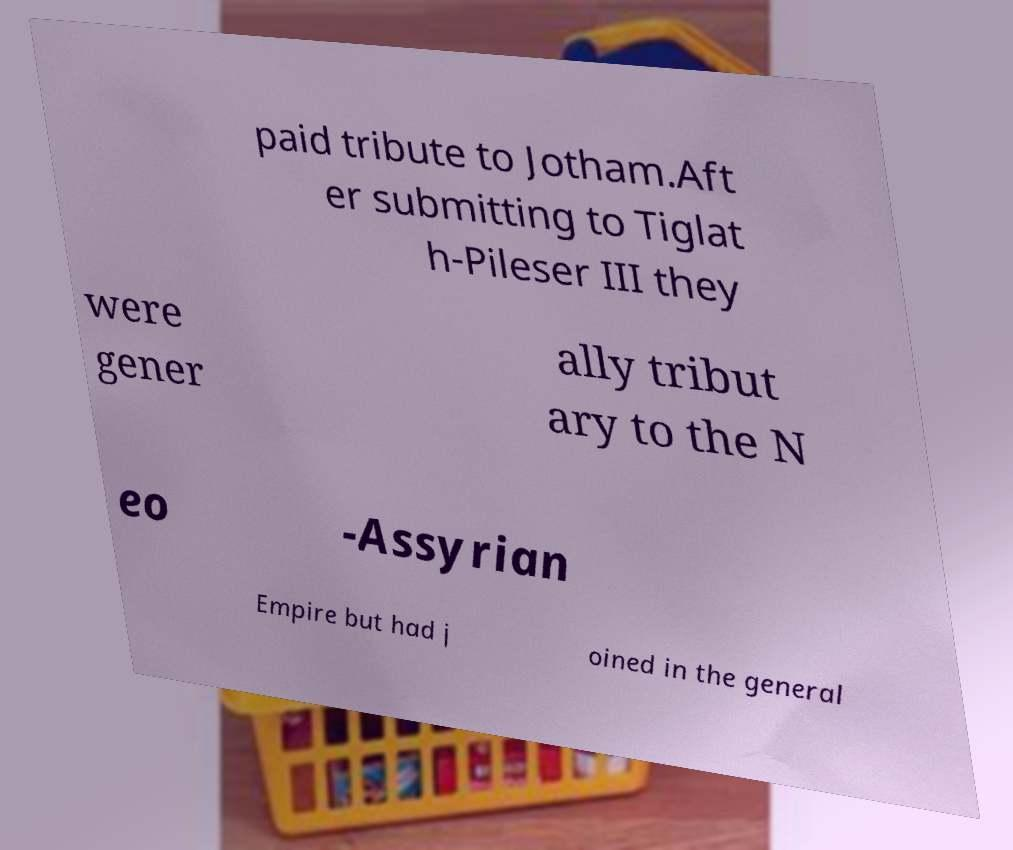Please identify and transcribe the text found in this image. paid tribute to Jotham.Aft er submitting to Tiglat h-Pileser III they were gener ally tribut ary to the N eo -Assyrian Empire but had j oined in the general 